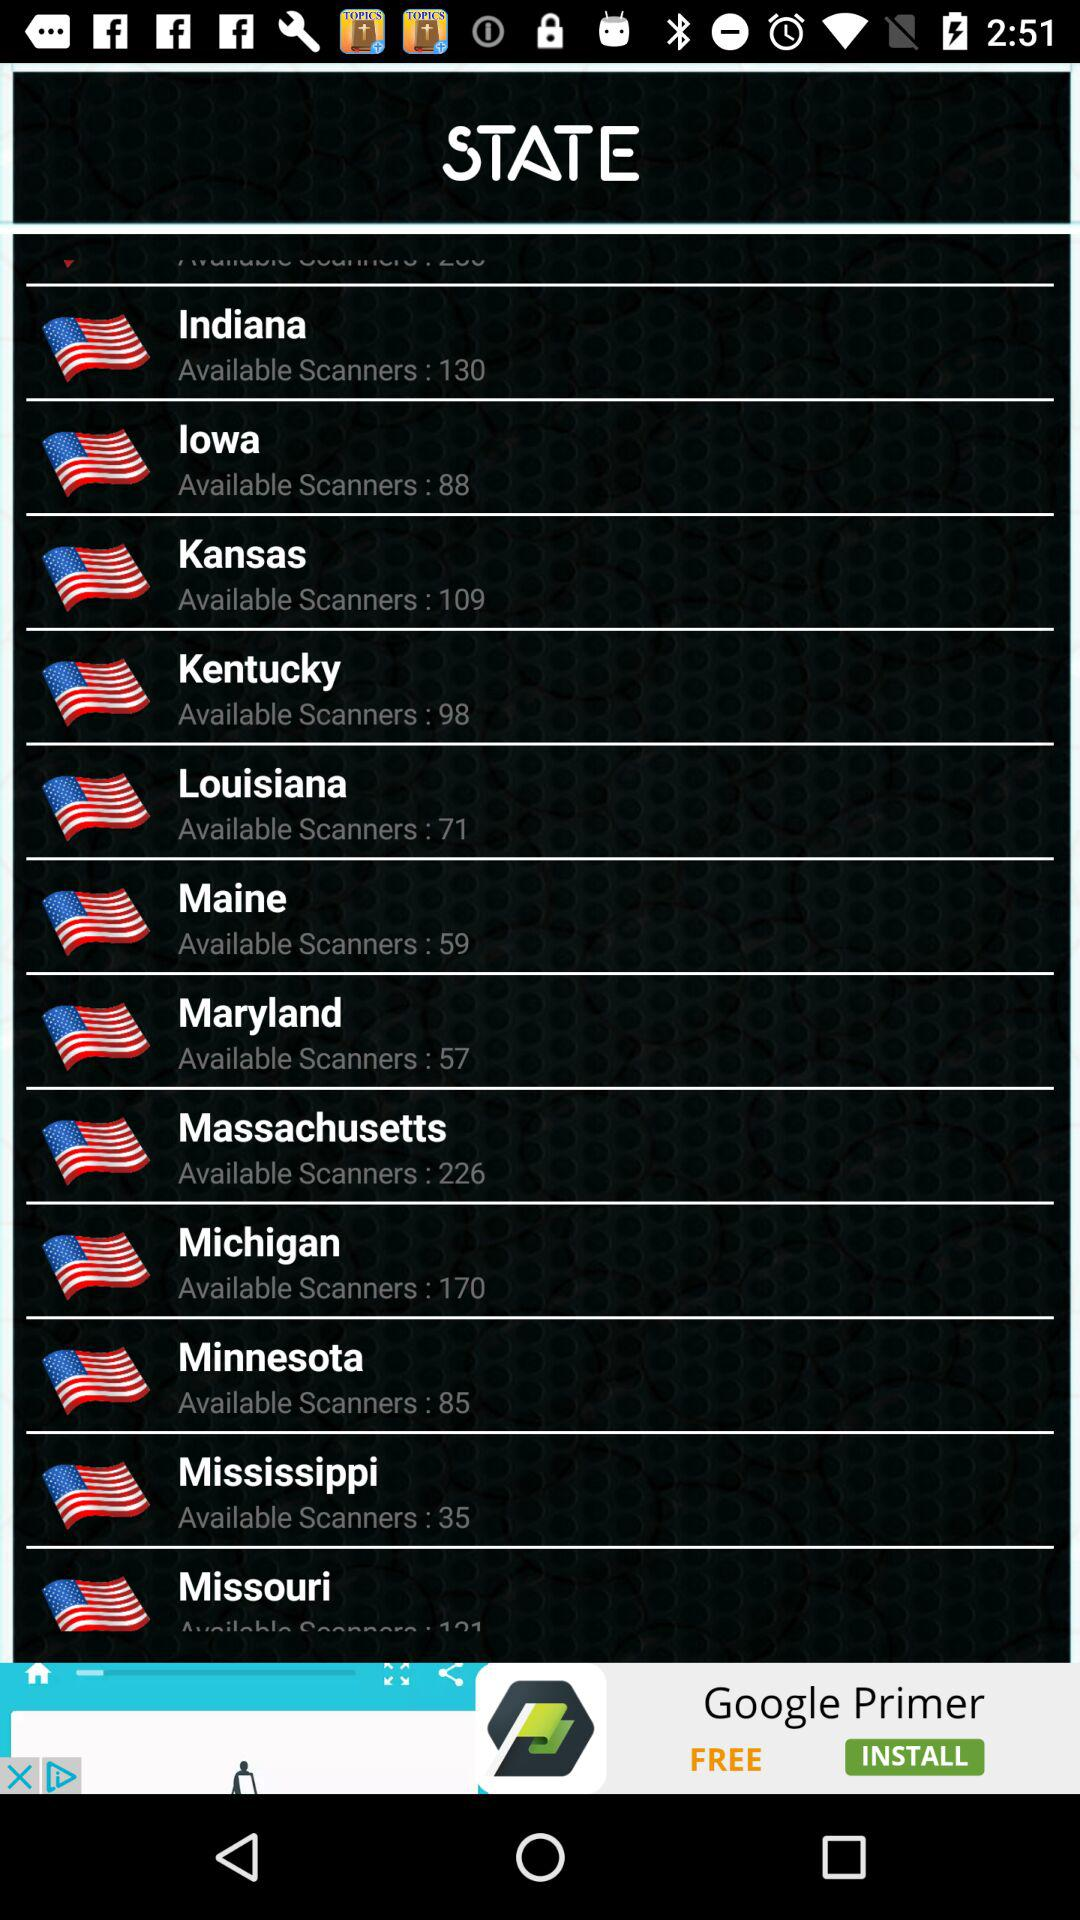What is the total number of available scanners in Maryland? The total number of available scanners in Maryland is 57. 